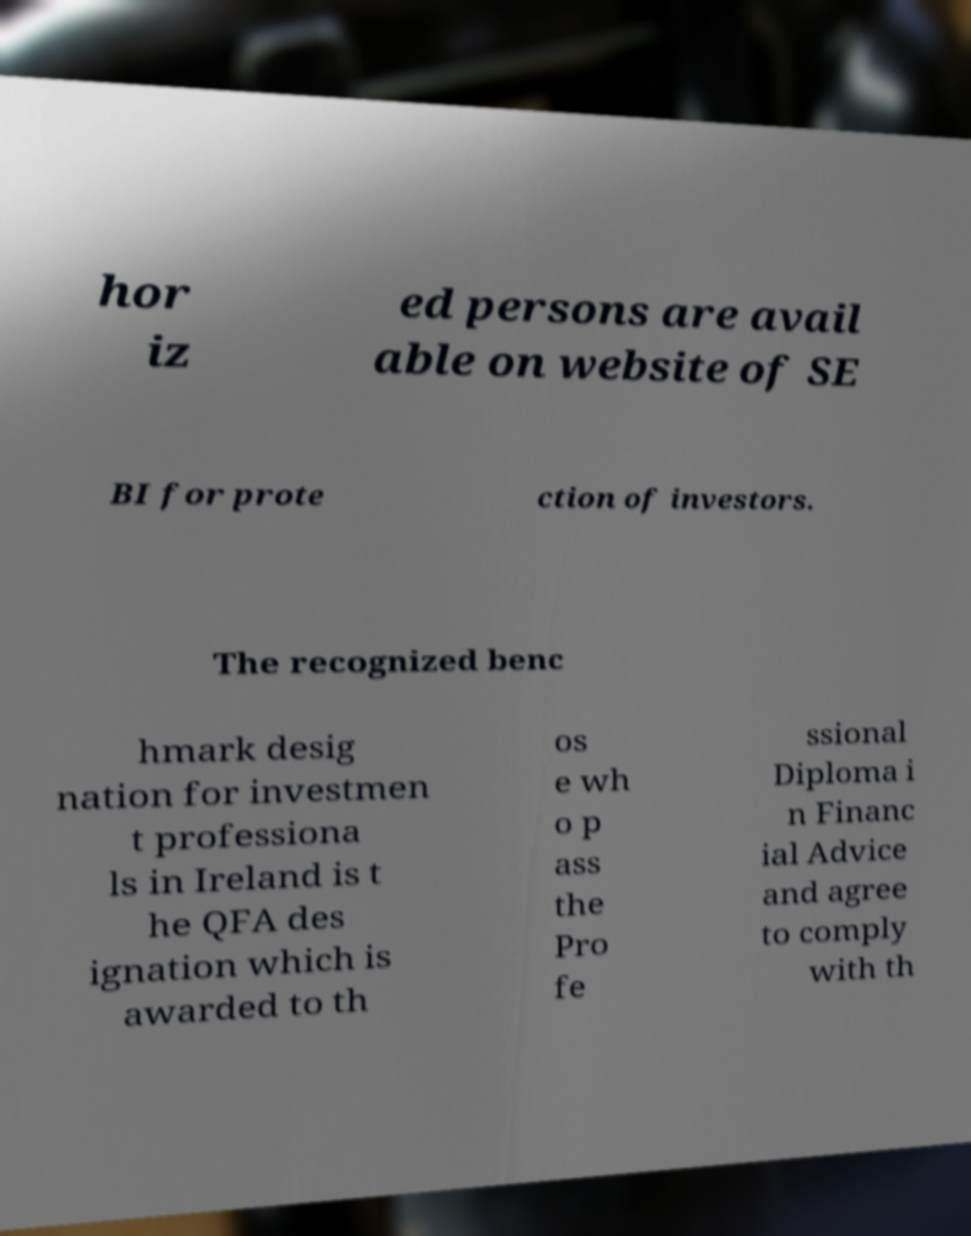What messages or text are displayed in this image? I need them in a readable, typed format. hor iz ed persons are avail able on website of SE BI for prote ction of investors. The recognized benc hmark desig nation for investmen t professiona ls in Ireland is t he QFA des ignation which is awarded to th os e wh o p ass the Pro fe ssional Diploma i n Financ ial Advice and agree to comply with th 